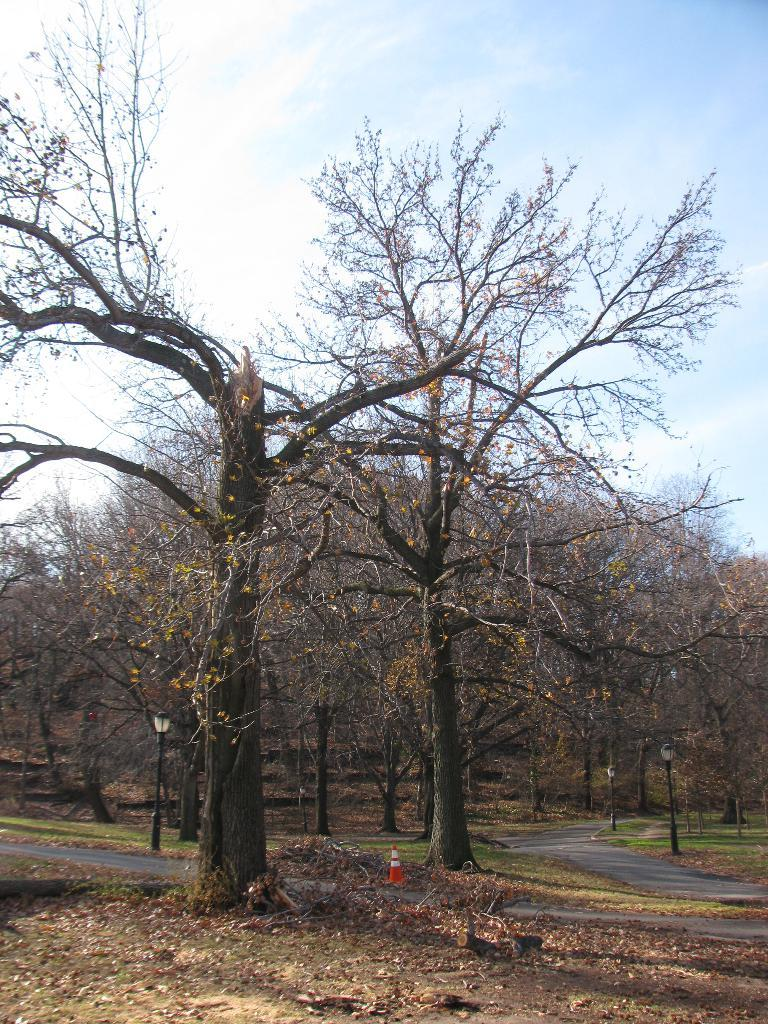What type of vegetation can be seen in the image? There are leaves and grass in the image. What man-made structure is present in the image? There is a road in the image. What safety feature is visible in the image? There is a traffic cone in the image. What type of lighting is present in the image? There are lights on poles in the image. What type of natural structure is present in the image? There are trees in the image. What part of the natural environment is visible in the background of the image? The sky is visible in the background of the image. What weather condition can be inferred from the image? The presence of clouds in the sky suggests that it might be partly cloudy. What type of credit card is being used to start the company in the image? There is no credit card or company being depicted in the image; it features leaves, grass, a road, a traffic cone, lights on poles, trees, and a sky with clouds. 